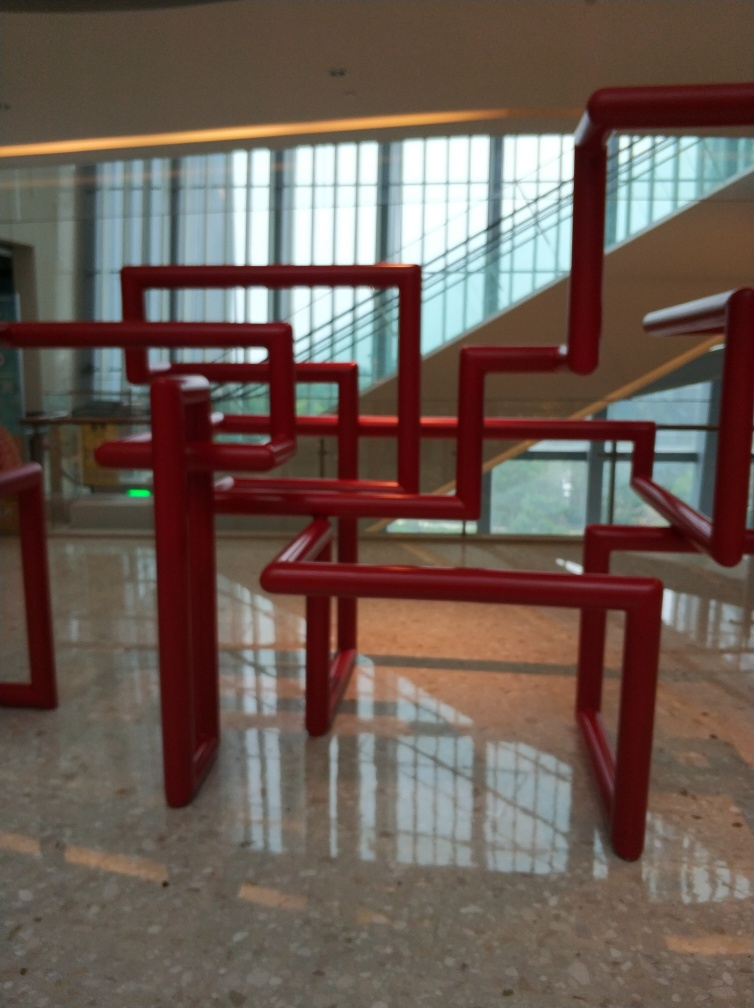Are there any quality issues with this image? The image appears to be slightly blurred, causing a loss of fine details. Additionally, the lighting seems uneven, and there might be some issues with the camera's focus. These elements collectively reduce the overall sharpness and clarity of the photograph. 